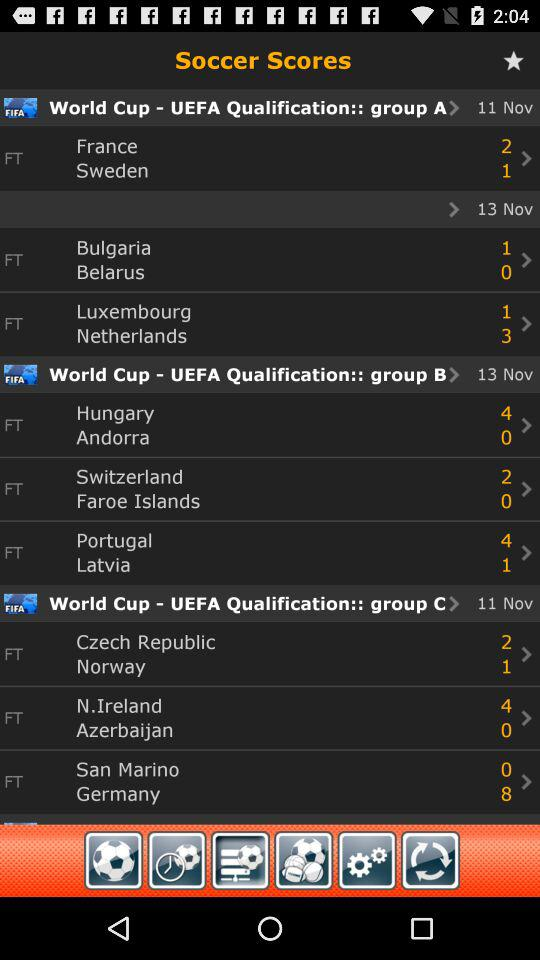How many more goals did France score than Bulgaria?
Answer the question using a single word or phrase. 1 